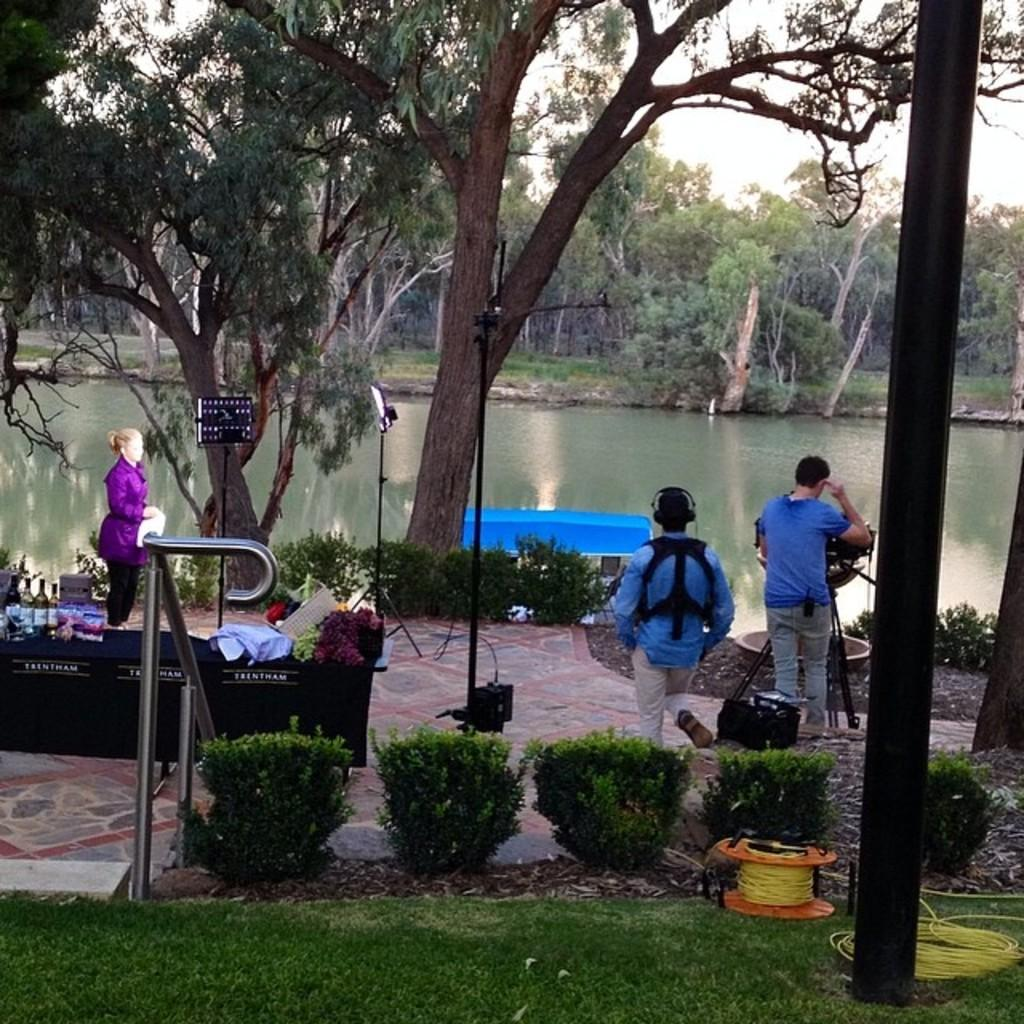What type of vegetation can be seen in the image? There is grass and plants visible in the image. What man-made structures are present in the image? There are wires, poles, and a bench in the image. What equipment is being used in the image? There is a camera on a tripod stand in the image. How many people are present in the image? There are three people standing in the image. What objects can be seen on a table in the image? There are bottles and other objects on a table in the image. What natural elements are visible in the image? There is water, trees, and sky visible in the image. Where is the crib located in the image? There is no crib present in the image. What type of boundary is visible in the image? There is no boundary visible in the image. 